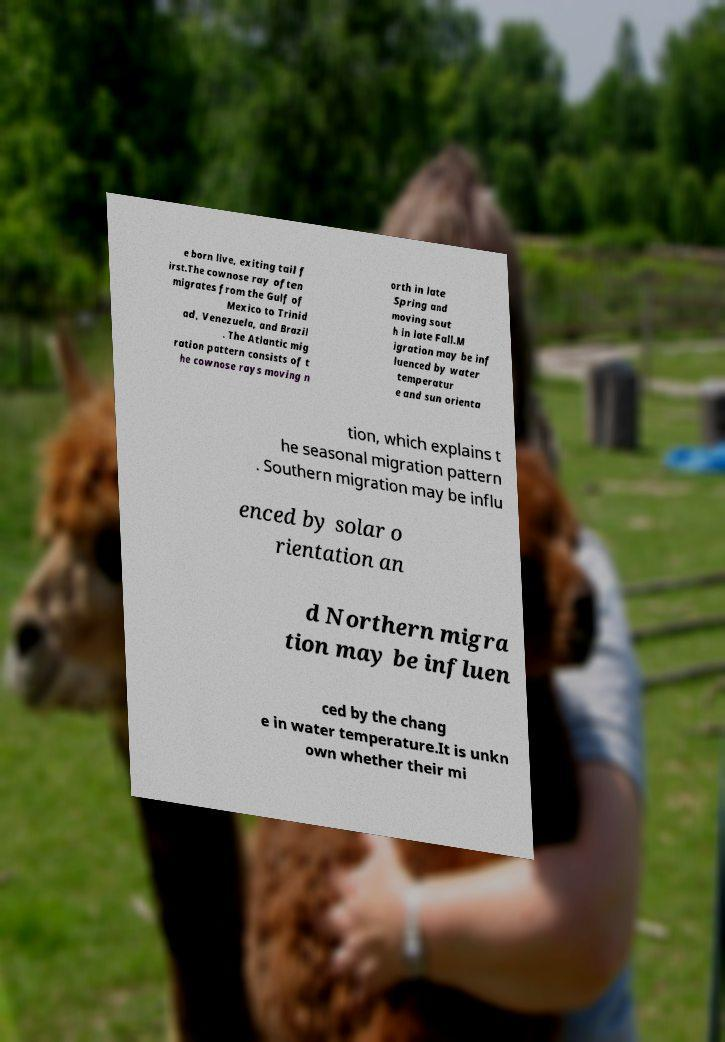Please read and relay the text visible in this image. What does it say? e born live, exiting tail f irst.The cownose ray often migrates from the Gulf of Mexico to Trinid ad, Venezuela, and Brazil . The Atlantic mig ration pattern consists of t he cownose rays moving n orth in late Spring and moving sout h in late Fall.M igration may be inf luenced by water temperatur e and sun orienta tion, which explains t he seasonal migration pattern . Southern migration may be influ enced by solar o rientation an d Northern migra tion may be influen ced by the chang e in water temperature.It is unkn own whether their mi 